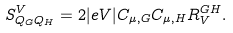<formula> <loc_0><loc_0><loc_500><loc_500>S ^ { V } _ { Q _ { G } Q _ { H } } = 2 | e V | C _ { \mu , G } C _ { \mu , H } R ^ { G H } _ { V } .</formula> 